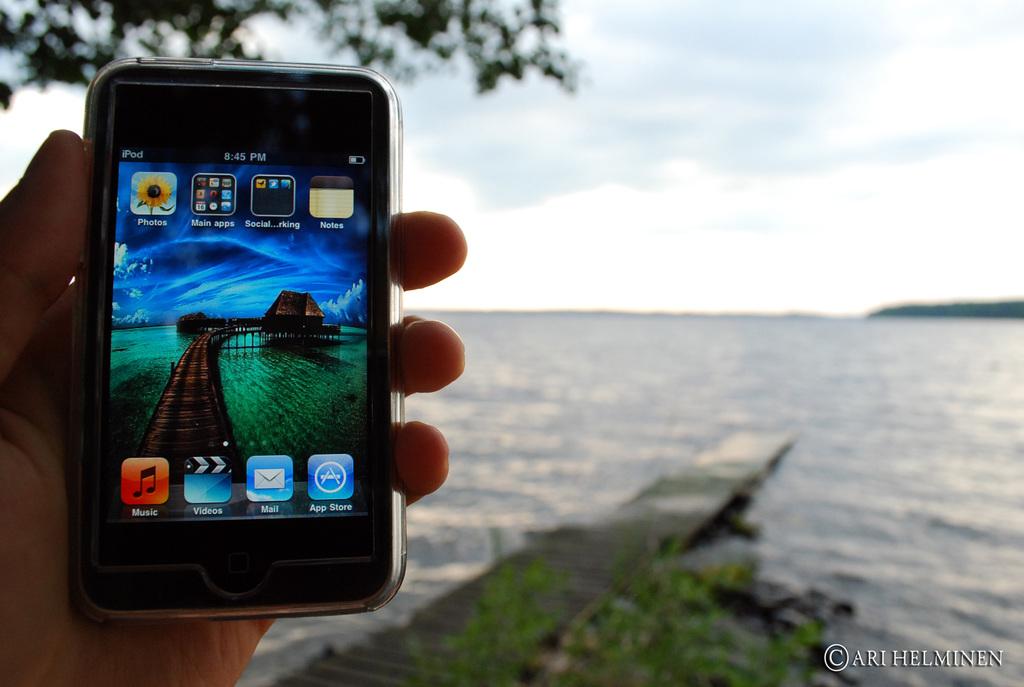What time is it according to the phone?
Provide a short and direct response. 8:45 pm. What app is in the bottom left corner?
Your answer should be compact. Music. 